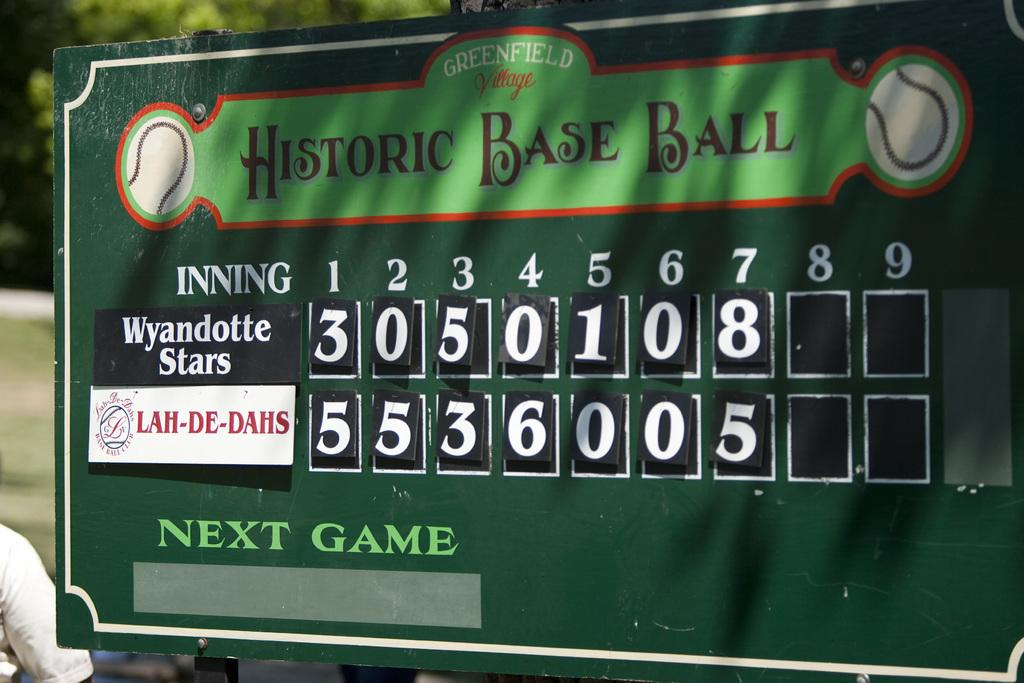<image>
Provide a brief description of the given image. a scoreboard with the words next game on it 